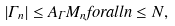Convert formula to latex. <formula><loc_0><loc_0><loc_500><loc_500>| \Gamma _ { n } | \leq A _ { \Gamma } M _ { n } f o r a l l n \leq N ,</formula> 